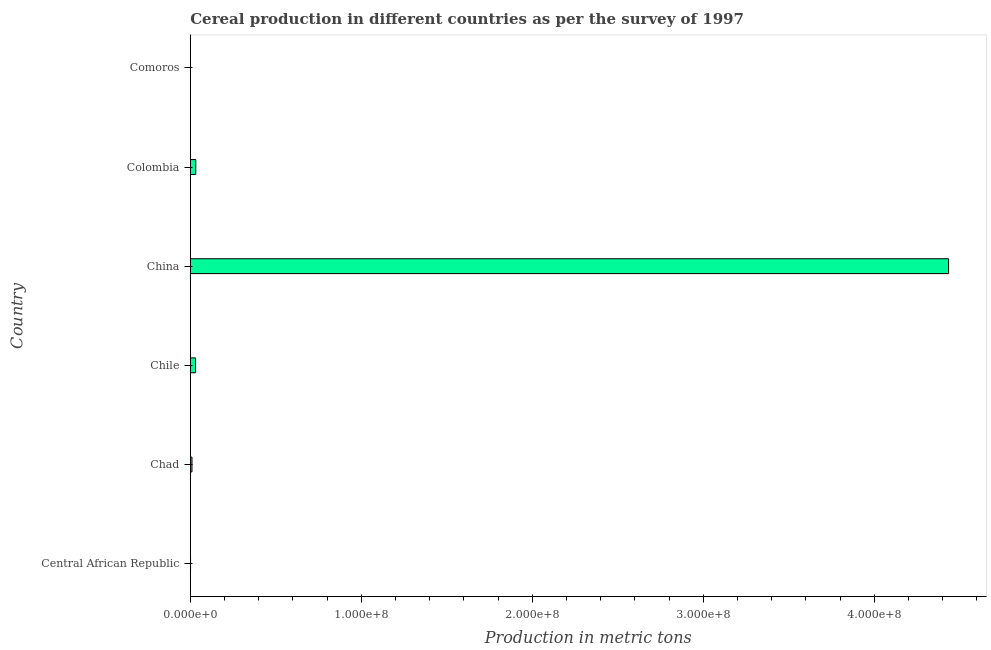Does the graph contain any zero values?
Offer a terse response. No. What is the title of the graph?
Provide a succinct answer. Cereal production in different countries as per the survey of 1997. What is the label or title of the X-axis?
Your response must be concise. Production in metric tons. What is the cereal production in Chile?
Make the answer very short. 3.08e+06. Across all countries, what is the maximum cereal production?
Ensure brevity in your answer.  4.43e+08. Across all countries, what is the minimum cereal production?
Offer a terse response. 2.04e+04. In which country was the cereal production minimum?
Make the answer very short. Comoros. What is the sum of the cereal production?
Your response must be concise. 4.51e+08. What is the difference between the cereal production in China and Colombia?
Provide a succinct answer. 4.40e+08. What is the average cereal production per country?
Your response must be concise. 7.52e+07. What is the median cereal production?
Your response must be concise. 2.03e+06. In how many countries, is the cereal production greater than 300000000 metric tons?
Your answer should be compact. 1. What is the difference between the highest and the second highest cereal production?
Your answer should be very brief. 4.40e+08. Is the sum of the cereal production in Chile and China greater than the maximum cereal production across all countries?
Your response must be concise. Yes. What is the difference between the highest and the lowest cereal production?
Your answer should be compact. 4.43e+08. How many bars are there?
Ensure brevity in your answer.  6. How many countries are there in the graph?
Ensure brevity in your answer.  6. What is the difference between two consecutive major ticks on the X-axis?
Provide a succinct answer. 1.00e+08. What is the Production in metric tons in Central African Republic?
Ensure brevity in your answer.  1.38e+05. What is the Production in metric tons in Chad?
Provide a succinct answer. 9.86e+05. What is the Production in metric tons in Chile?
Provide a succinct answer. 3.08e+06. What is the Production in metric tons of China?
Ensure brevity in your answer.  4.43e+08. What is the Production in metric tons of Colombia?
Your response must be concise. 3.21e+06. What is the Production in metric tons in Comoros?
Give a very brief answer. 2.04e+04. What is the difference between the Production in metric tons in Central African Republic and Chad?
Offer a terse response. -8.47e+05. What is the difference between the Production in metric tons in Central African Republic and Chile?
Keep it short and to the point. -2.94e+06. What is the difference between the Production in metric tons in Central African Republic and China?
Make the answer very short. -4.43e+08. What is the difference between the Production in metric tons in Central African Republic and Colombia?
Give a very brief answer. -3.07e+06. What is the difference between the Production in metric tons in Central African Republic and Comoros?
Offer a very short reply. 1.18e+05. What is the difference between the Production in metric tons in Chad and Chile?
Keep it short and to the point. -2.09e+06. What is the difference between the Production in metric tons in Chad and China?
Give a very brief answer. -4.43e+08. What is the difference between the Production in metric tons in Chad and Colombia?
Keep it short and to the point. -2.22e+06. What is the difference between the Production in metric tons in Chad and Comoros?
Give a very brief answer. 9.65e+05. What is the difference between the Production in metric tons in Chile and China?
Provide a succinct answer. -4.40e+08. What is the difference between the Production in metric tons in Chile and Colombia?
Ensure brevity in your answer.  -1.30e+05. What is the difference between the Production in metric tons in Chile and Comoros?
Make the answer very short. 3.06e+06. What is the difference between the Production in metric tons in China and Colombia?
Offer a terse response. 4.40e+08. What is the difference between the Production in metric tons in China and Comoros?
Ensure brevity in your answer.  4.43e+08. What is the difference between the Production in metric tons in Colombia and Comoros?
Give a very brief answer. 3.19e+06. What is the ratio of the Production in metric tons in Central African Republic to that in Chad?
Offer a terse response. 0.14. What is the ratio of the Production in metric tons in Central African Republic to that in Chile?
Your response must be concise. 0.04. What is the ratio of the Production in metric tons in Central African Republic to that in Colombia?
Keep it short and to the point. 0.04. What is the ratio of the Production in metric tons in Central African Republic to that in Comoros?
Your answer should be very brief. 6.78. What is the ratio of the Production in metric tons in Chad to that in Chile?
Your answer should be compact. 0.32. What is the ratio of the Production in metric tons in Chad to that in China?
Keep it short and to the point. 0. What is the ratio of the Production in metric tons in Chad to that in Colombia?
Your answer should be very brief. 0.31. What is the ratio of the Production in metric tons in Chad to that in Comoros?
Your answer should be very brief. 48.28. What is the ratio of the Production in metric tons in Chile to that in China?
Give a very brief answer. 0.01. What is the ratio of the Production in metric tons in Chile to that in Comoros?
Your answer should be compact. 150.72. What is the ratio of the Production in metric tons in China to that in Colombia?
Ensure brevity in your answer.  138.28. What is the ratio of the Production in metric tons in China to that in Comoros?
Your answer should be compact. 2.17e+04. What is the ratio of the Production in metric tons in Colombia to that in Comoros?
Provide a succinct answer. 157.08. 